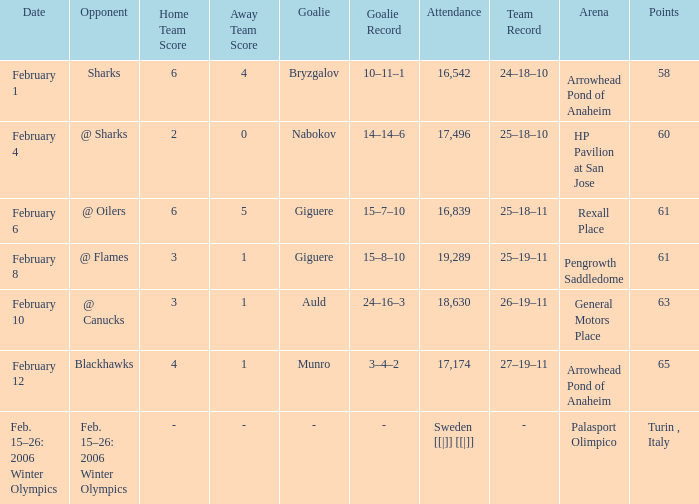What were the tallies on the 10th of february? 63.0. 